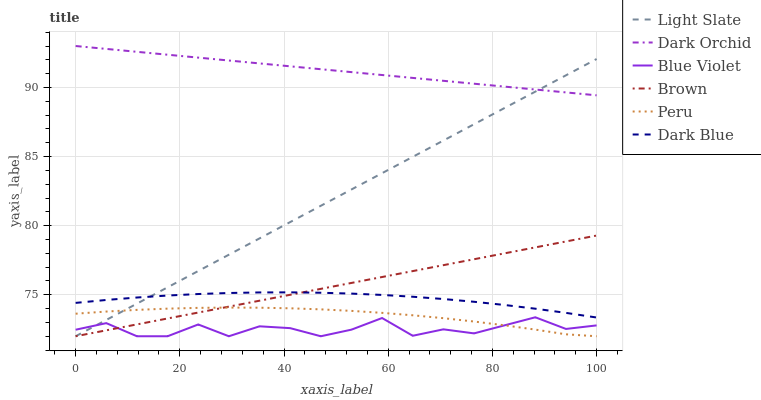Does Blue Violet have the minimum area under the curve?
Answer yes or no. Yes. Does Dark Orchid have the maximum area under the curve?
Answer yes or no. Yes. Does Light Slate have the minimum area under the curve?
Answer yes or no. No. Does Light Slate have the maximum area under the curve?
Answer yes or no. No. Is Brown the smoothest?
Answer yes or no. Yes. Is Blue Violet the roughest?
Answer yes or no. Yes. Is Light Slate the smoothest?
Answer yes or no. No. Is Light Slate the roughest?
Answer yes or no. No. Does Brown have the lowest value?
Answer yes or no. Yes. Does Dark Orchid have the lowest value?
Answer yes or no. No. Does Dark Orchid have the highest value?
Answer yes or no. Yes. Does Light Slate have the highest value?
Answer yes or no. No. Is Peru less than Dark Blue?
Answer yes or no. Yes. Is Dark Orchid greater than Peru?
Answer yes or no. Yes. Does Light Slate intersect Blue Violet?
Answer yes or no. Yes. Is Light Slate less than Blue Violet?
Answer yes or no. No. Is Light Slate greater than Blue Violet?
Answer yes or no. No. Does Peru intersect Dark Blue?
Answer yes or no. No. 